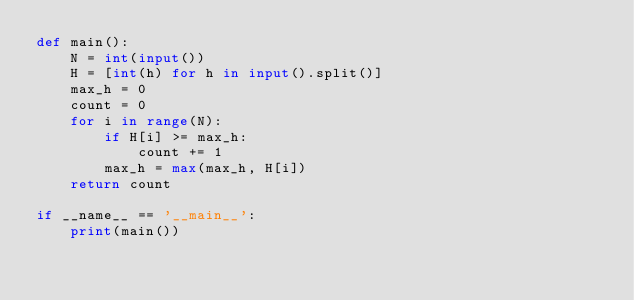<code> <loc_0><loc_0><loc_500><loc_500><_Python_>def main():
    N = int(input())
    H = [int(h) for h in input().split()]
    max_h = 0
    count = 0
    for i in range(N):
        if H[i] >= max_h:
            count += 1
        max_h = max(max_h, H[i])
    return count

if __name__ == '__main__':
    print(main())</code> 